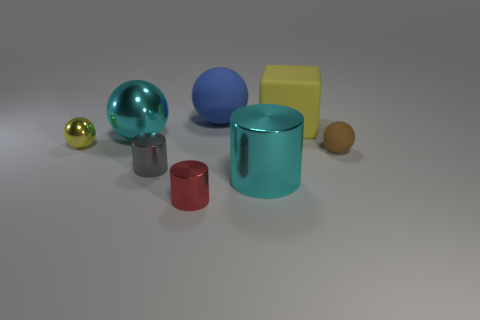Are any tiny objects visible?
Give a very brief answer. Yes. Do the matte thing that is behind the big block and the yellow object behind the small yellow thing have the same size?
Your answer should be compact. Yes. The object that is both left of the big yellow object and to the right of the large blue rubber thing is made of what material?
Offer a terse response. Metal. There is a large cyan sphere; what number of small red cylinders are behind it?
Provide a short and direct response. 0. Is there any other thing that has the same size as the cyan ball?
Your response must be concise. Yes. There is another tiny cylinder that is the same material as the tiny red cylinder; what is its color?
Provide a succinct answer. Gray. Do the small gray thing and the large blue rubber thing have the same shape?
Offer a very short reply. No. How many small objects are in front of the small gray metallic thing and to the left of the cyan sphere?
Provide a succinct answer. 0. What number of rubber objects are either large balls or large yellow objects?
Your answer should be very brief. 2. What size is the ball that is on the right side of the sphere behind the big yellow matte cube?
Your answer should be compact. Small. 